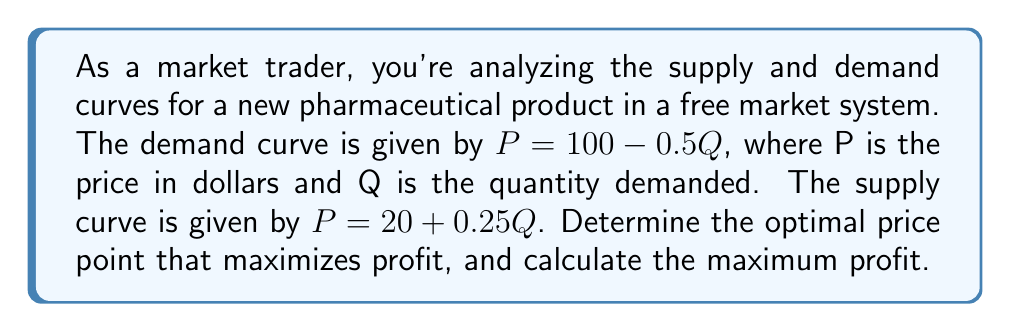What is the answer to this math problem? To solve this problem, we'll follow these steps:

1) Find the equilibrium point by equating supply and demand:
   $100 - 0.5Q = 20 + 0.25Q$
   $80 = 0.75Q$
   $Q = 106.67$

   Substituting this back into either equation gives us $P = \$46.67$

2) The profit-maximizing point occurs where marginal revenue (MR) equals marginal cost (MC).

3) For a linear demand curve $P = a - bQ$, the marginal revenue curve is $MR = a - 2bQ$.
   So, $MR = 100 - Q$

4) The marginal cost curve is the same as the supply curve: $MC = 20 + 0.25Q$

5) Set MR = MC:
   $100 - Q = 20 + 0.25Q$
   $80 = 1.25Q$
   $Q = 64$

6) Substitute this Q back into the demand equation to find P:
   $P = 100 - 0.5(64) = \$68$

7) To calculate the maximum profit:
   Revenue = $P * Q = 68 * 64 = \$4,352$
   Cost = Area under the supply curve = $20Q + 0.125Q^2 = 20(64) + 0.125(64^2) = \$1,280 + \$512 = \$1,792$
   Profit = Revenue - Cost = $4,352 - 1,792 = \$2,560$

[asy]
size(200,200);
import graph;

real f(real x) {return 100-0.5x;}
real g(real x) {return 20+0.25x;}

draw(graph(f,0,106.67),blue);
draw(graph(g,0,106.67),red);

label("Demand",(-5,100),blue);
label("Supply",(110,45),red);

dot((64,68));
label("($64, $68)",(64,68),NE);

xaxis("Quantity",arrow=Arrow);
yaxis("Price ($)",arrow=Arrow);
</asy]
Answer: The optimal price point to maximize profit is $\$68$, with a quantity of 64 units. The maximum profit at this point is $\$2,560$. 